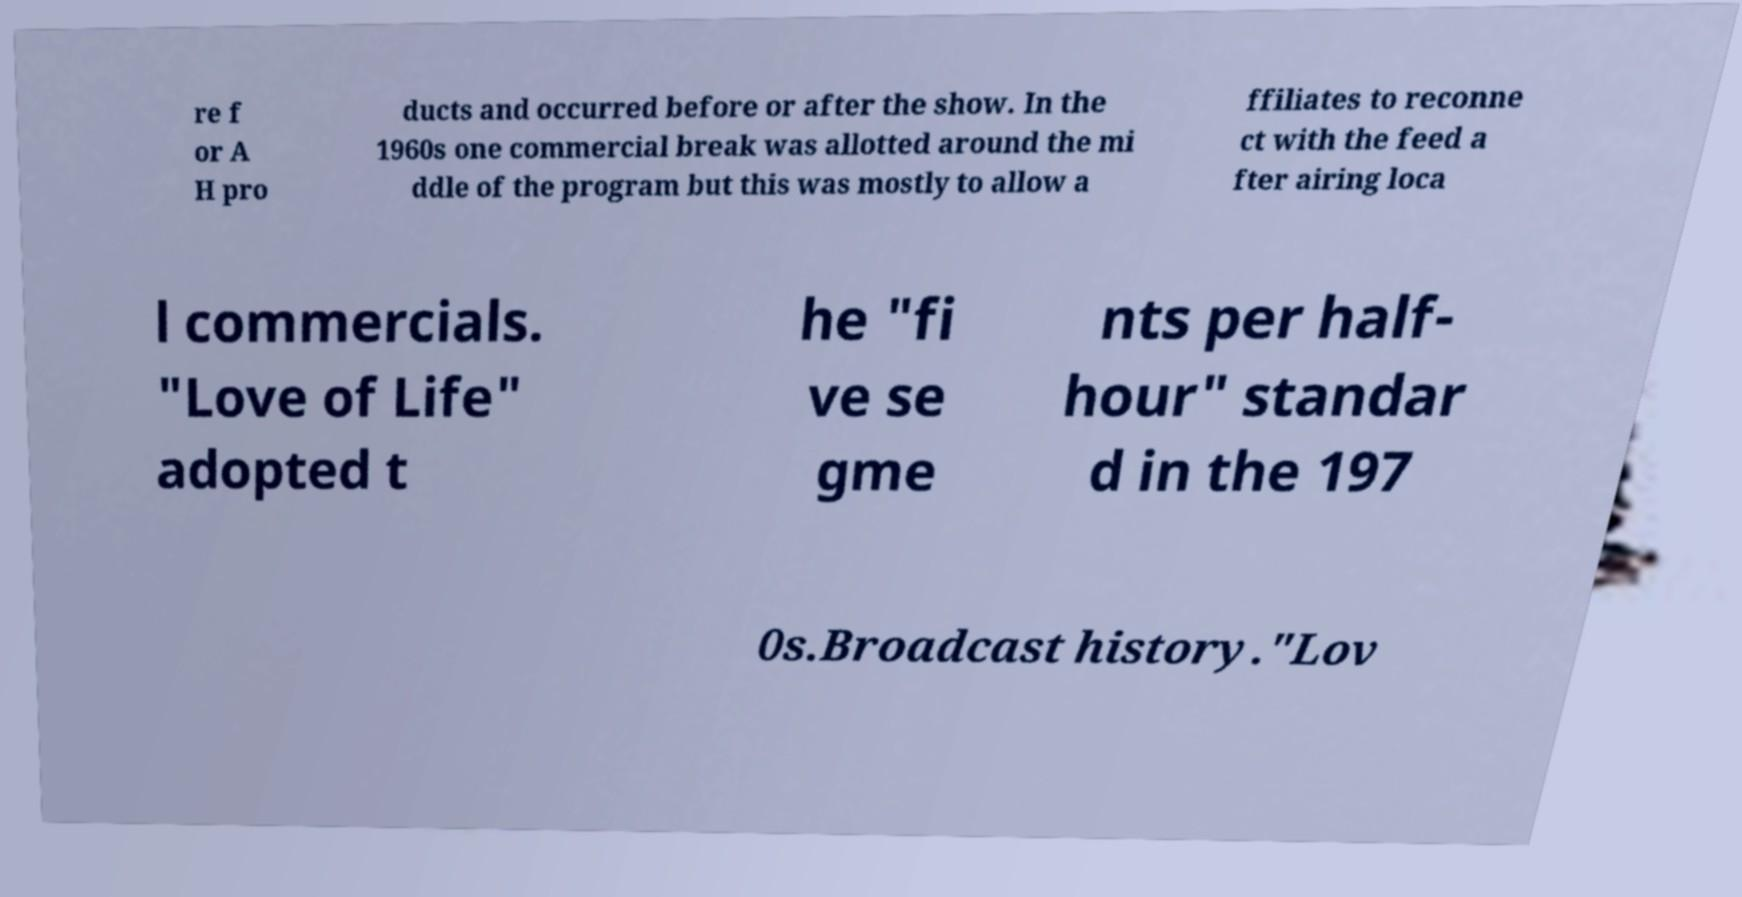Could you assist in decoding the text presented in this image and type it out clearly? re f or A H pro ducts and occurred before or after the show. In the 1960s one commercial break was allotted around the mi ddle of the program but this was mostly to allow a ffiliates to reconne ct with the feed a fter airing loca l commercials. "Love of Life" adopted t he "fi ve se gme nts per half- hour" standar d in the 197 0s.Broadcast history."Lov 